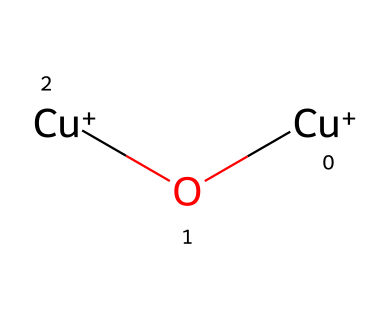how many copper atoms are in this structure? The SMILES representation indicates there are two instances of copper (Cu) in the structure indicated with the symbol 'Cu+' appearing twice.
Answer: 2 what type of bonding does the copper exhibit in this structure? The structure shows copper ions represented as Cu+, which indicates they are positively charged and involved in ionic bonding, often forming coordination complexes.
Answer: ionic what is the oxidation state of copper in this chemical? The notation 'Cu+' indicates that copper is in a +1 oxidation state, denoting it has lost one electron.
Answer: +1 how many oxygen atoms are present in this structure? The chemical structure also shows one oxygen atom represented by 'O' in the SMILES, making it a total of one oxygen atom.
Answer: 1 what is the potential environmental impact of this copper-based chemical? Copper, when released into marine environments as an antifouling agent, can be toxic to coral reefs and marine organisms, leading to ecological damage.
Answer: toxic what type of material is this chemical structure likely to form in antifouling applications? The structure indicates the presence of metal ions, which typically leads to the formation of solid coatings known as antifouling paints on boat hulls.
Answer: solid coating what characteristic property does the presence of copper in this compound impart? Copper compounds are known for their biocidal properties, making them effective in preventing the growth of algae and barnacles on surfaces submerged in water.
Answer: biocidal 